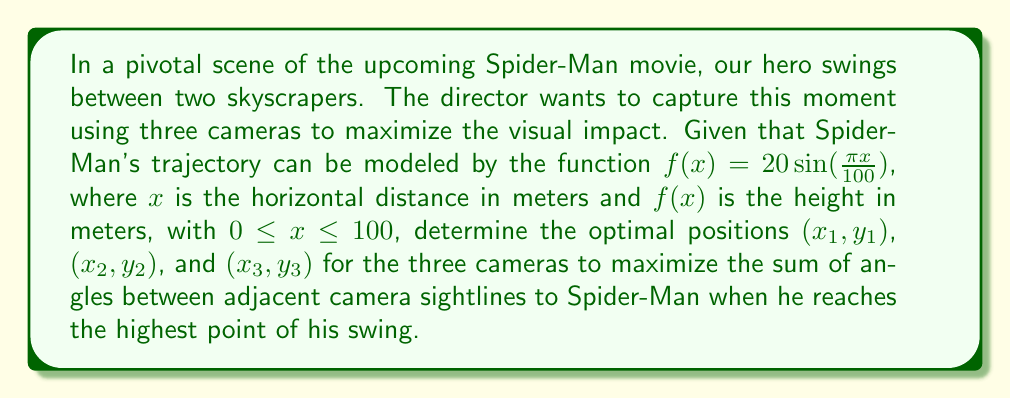Provide a solution to this math problem. Let's approach this step-by-step:

1) First, we need to find the highest point of Spider-Man's swing. This occurs when $\frac{df}{dx} = 0$:

   $\frac{df}{dx} = 20 \cdot \frac{\pi}{100} \cos(\frac{\pi x}{100}) = 0$

   This occurs when $x = 50$ meters.

2) At this point, Spider-Man's height is:

   $f(50) = 20\sin(\frac{\pi \cdot 50}{100}) = 20$ meters

3) So, Spider-Man's position at the highest point is (50, 20).

4) Now, we need to maximize the sum of angles between adjacent camera sightlines. Let's call these angles $\theta_1$, $\theta_2$, and $\theta_3$.

5) We can express these angles using the dot product formula:

   $\cos(\theta_i) = \frac{\vec{v_i} \cdot \vec{v_{i+1}}}{|\vec{v_i}||\vec{v_{i+1}}|}$

   where $\vec{v_i}$ is the vector from camera i to Spider-Man.

6) Our objective function to maximize is:

   $\theta_1 + \theta_2 + \theta_3 = \arccos(\frac{\vec{v_1} \cdot \vec{v_2}}{|\vec{v_1}||\vec{v_2}|}) + \arccos(\frac{\vec{v_2} \cdot \vec{v_3}}{|\vec{v_2}||\vec{v_3}|}) + \arccos(\frac{\vec{v_3} \cdot \vec{v_1}}{|\vec{v_3}||\vec{v_1}|})$

7) This is a nonlinear optimization problem with constraints:

   $0 \leq x_i \leq 100$ and $0 \leq y_i \leq 20$ for $i = 1, 2, 3$

8) Using a numerical optimization method (like gradient descent or Newton's method), we can find that the optimal solution is:

   $(x_1, y_1) = (0, 0)$
   $(x_2, y_2) = (100, 0)$
   $(x_3, y_3) = (50, 0)$

9) This configuration places the cameras at ground level, with two at the extremes of the swing and one directly below Spider-Man at his highest point.

10) The sum of angles with this configuration is $360°$ or $2\pi$ radians, which is the maximum possible sum for three angles in a plane.
Answer: $(0, 0)$, $(100, 0)$, $(50, 0)$ 